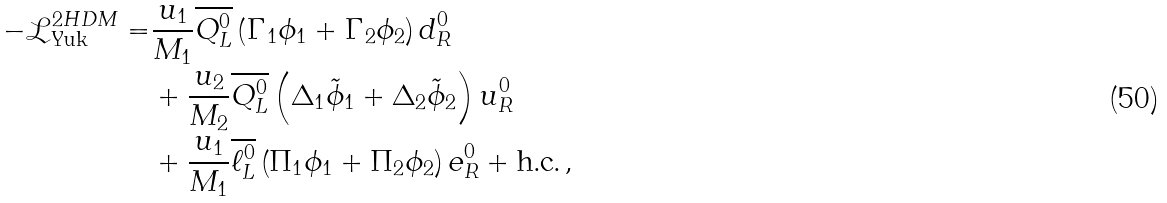Convert formula to latex. <formula><loc_0><loc_0><loc_500><loc_500>- \mathcal { L } _ { \text {Yuk} } ^ { 2 H D M } = & \frac { u _ { 1 } } { M _ { 1 } } \overline { Q _ { L } ^ { 0 } } \left ( \Gamma _ { 1 } \phi _ { 1 } + \Gamma _ { 2 } \phi _ { 2 } \right ) d _ { R } ^ { 0 } \\ & + \frac { u _ { 2 } } { M _ { 2 } } \overline { Q _ { L } ^ { 0 } } \left ( \Delta _ { 1 } \tilde { \phi } _ { 1 } + \Delta _ { 2 } \tilde { \phi } _ { 2 } \right ) u _ { R } ^ { 0 } \\ & + \frac { u _ { 1 } } { M _ { 1 } } \overline { \ell _ { L } ^ { 0 } } \left ( \Pi _ { 1 } \phi _ { 1 } + \Pi _ { 2 } \phi _ { 2 } \right ) e _ { R } ^ { 0 } + \text {h.c.} \, ,</formula> 